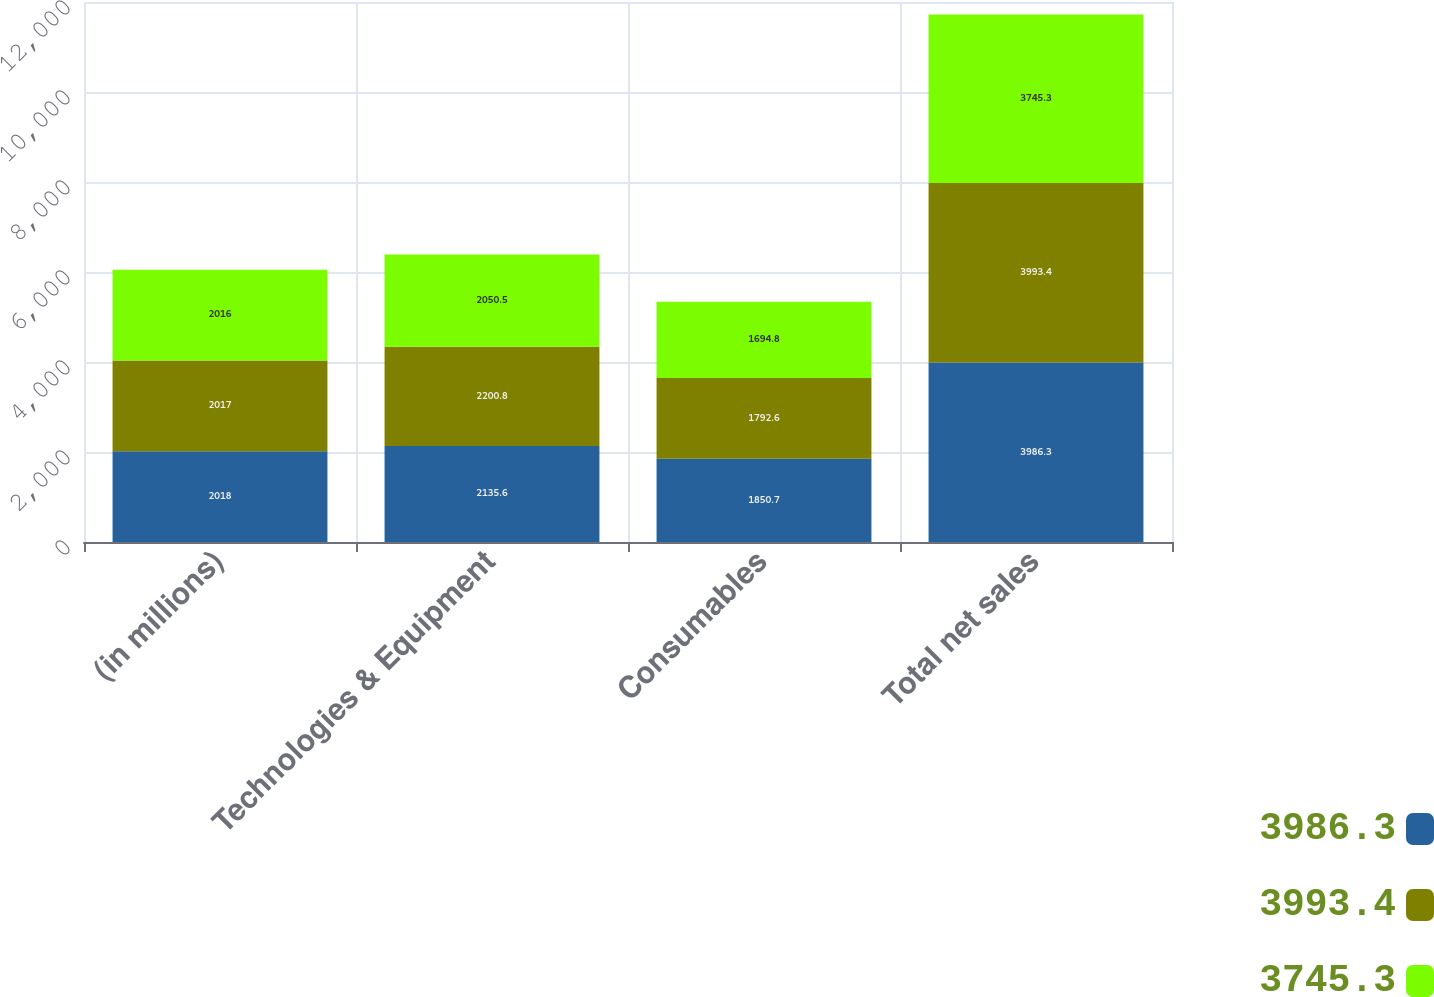<chart> <loc_0><loc_0><loc_500><loc_500><stacked_bar_chart><ecel><fcel>(in millions)<fcel>Technologies & Equipment<fcel>Consumables<fcel>Total net sales<nl><fcel>3986.3<fcel>2018<fcel>2135.6<fcel>1850.7<fcel>3986.3<nl><fcel>3993.4<fcel>2017<fcel>2200.8<fcel>1792.6<fcel>3993.4<nl><fcel>3745.3<fcel>2016<fcel>2050.5<fcel>1694.8<fcel>3745.3<nl></chart> 